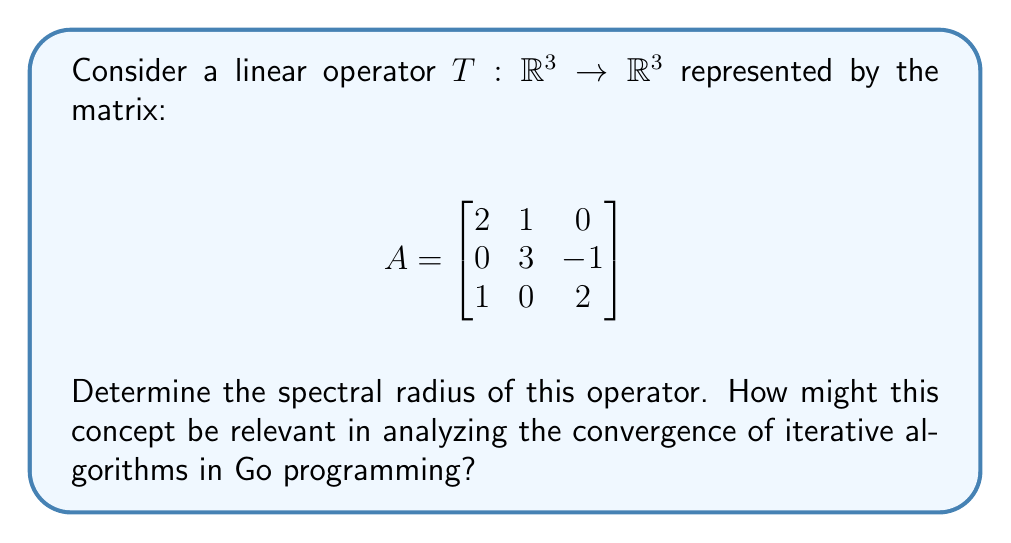What is the answer to this math problem? To determine the spectral radius of the linear operator T, we follow these steps:

1) First, we need to find the eigenvalues of the matrix A. The characteristic equation is:

   $$det(A - \lambda I) = \begin{vmatrix}
   2-\lambda & 1 & 0 \\
   0 & 3-\lambda & -1 \\
   1 & 0 & 2-\lambda
   \end{vmatrix} = 0$$

2) Expanding this determinant:
   
   $$(2-\lambda)[(3-\lambda)(2-\lambda) + 1] - 1(2-\lambda) = 0$$
   $$(2-\lambda)(6-5\lambda+\lambda^2 + 1) - (2-\lambda) = 0$$
   $$(2-\lambda)(7-5\lambda+\lambda^2) - (2-\lambda) = 0$$
   $$14-10\lambda+2\lambda^2-7\lambda+5\lambda^2-\lambda^3 - 2 + \lambda = 0$$
   $$-\lambda^3 + 7\lambda^2 - 16\lambda + 12 = 0$$

3) This cubic equation can be factored as:

   $$(\lambda - 2)(\lambda - 2)(\lambda - 3) = 0$$

4) Therefore, the eigenvalues are $\lambda_1 = 2$ (with algebraic multiplicity 2) and $\lambda_2 = 3$.

5) The spectral radius $\rho(T)$ is defined as the maximum of the absolute values of the eigenvalues:

   $$\rho(T) = \max\{|\lambda_1|, |\lambda_2|\} = \max\{|2|, |3|\} = 3$$

In Go programming, understanding the spectral radius is crucial when implementing iterative algorithms, such as those used in machine learning or numerical simulations. The spectral radius determines the convergence rate of iterative methods. If the spectral radius is less than 1, the iteration will converge; if it's greater than 1, it will diverge. In this case, with a spectral radius of 3, an iterative algorithm based on this operator would diverge, indicating a need for modification or a different approach in the implementation.
Answer: $\rho(T) = 3$ 